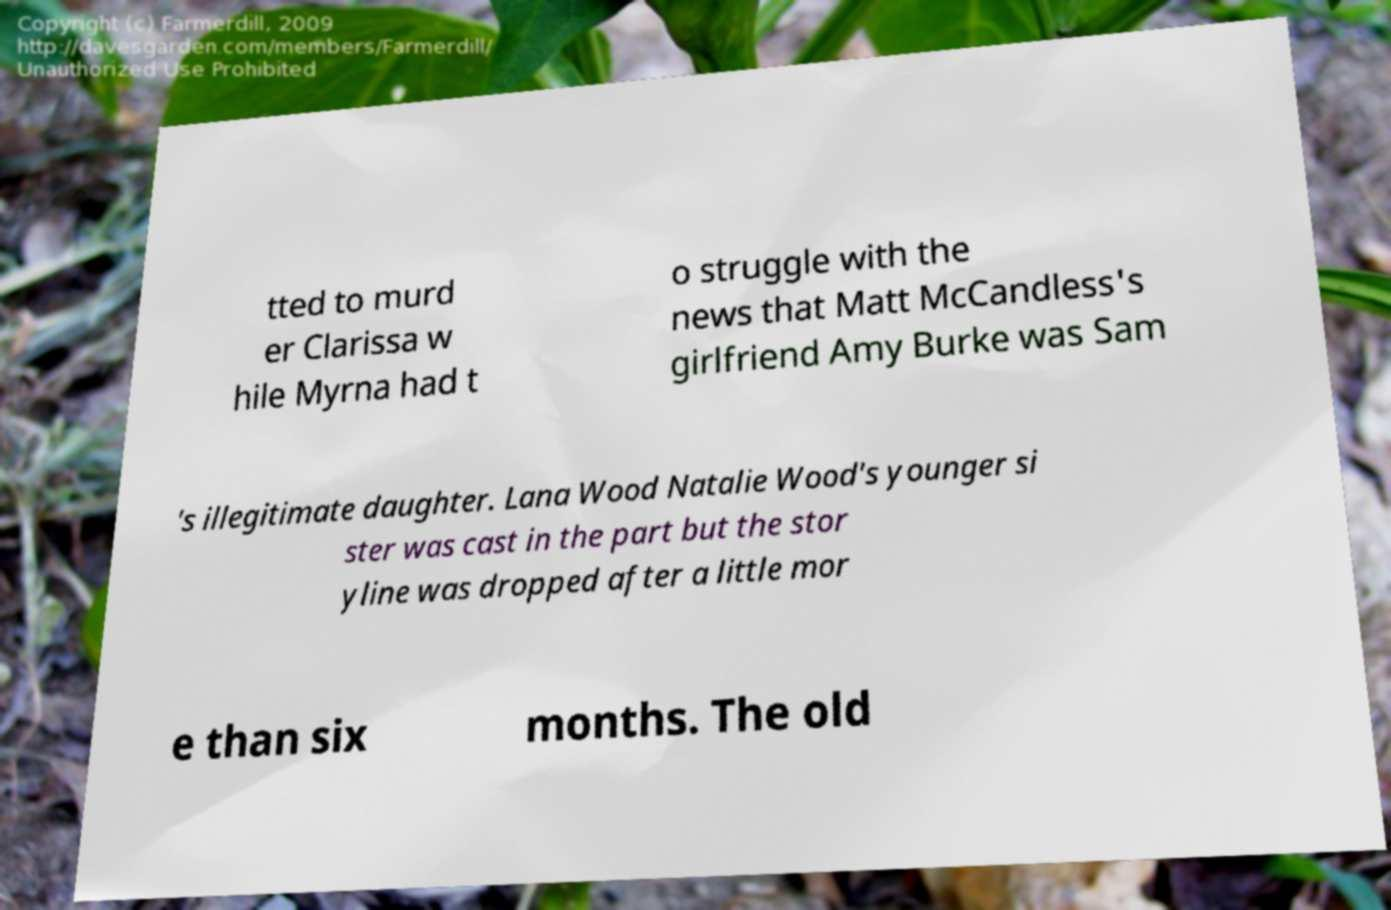Could you assist in decoding the text presented in this image and type it out clearly? tted to murd er Clarissa w hile Myrna had t o struggle with the news that Matt McCandless's girlfriend Amy Burke was Sam 's illegitimate daughter. Lana Wood Natalie Wood's younger si ster was cast in the part but the stor yline was dropped after a little mor e than six months. The old 